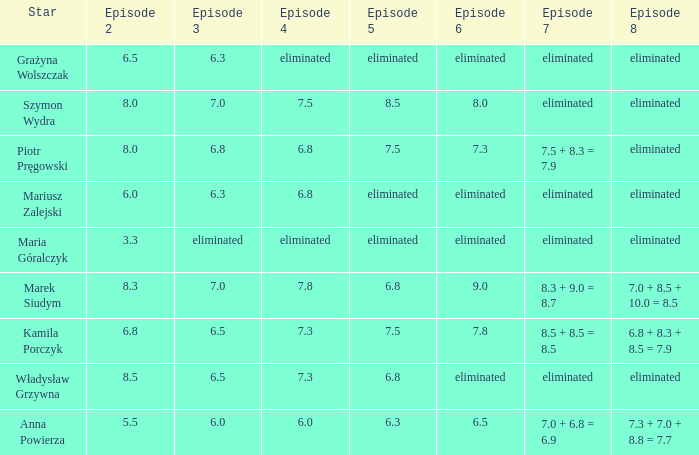Which episode 4 has a Star of anna powierza? 6.0. 